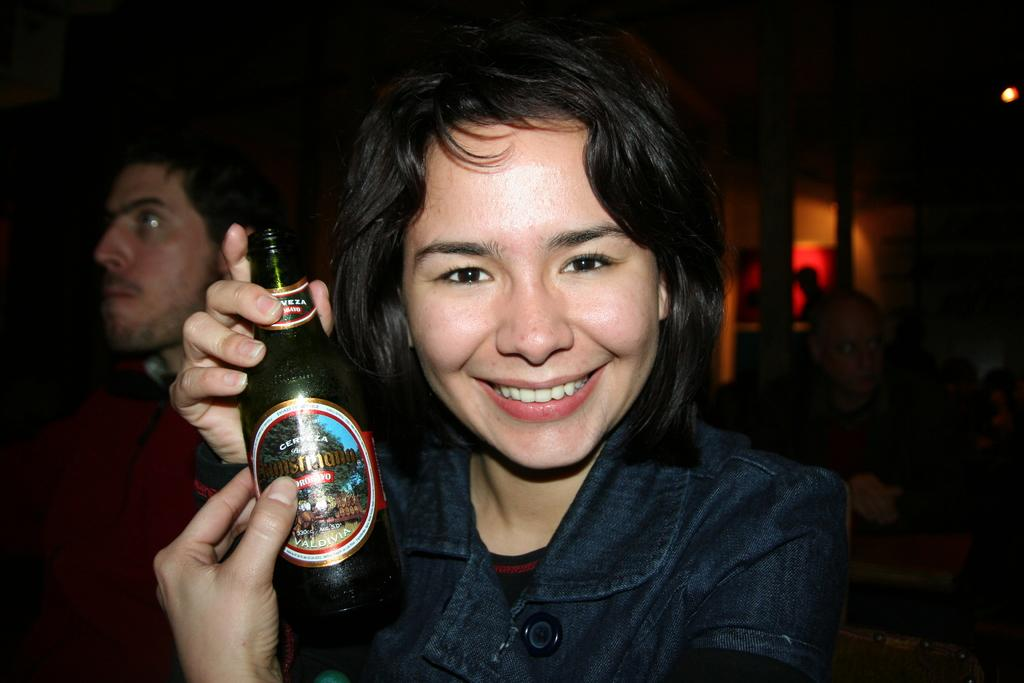Who is present in the image? There is a woman and a man in the image. What is the woman holding in the image? The woman is holding a beer bottle. What expression does the woman have on her face? The woman has a smile on her face. What type of news can be heard coming from the minister in the image? There is no minister present in the image, so it's not possible to determine what, if any, news might be heard. 